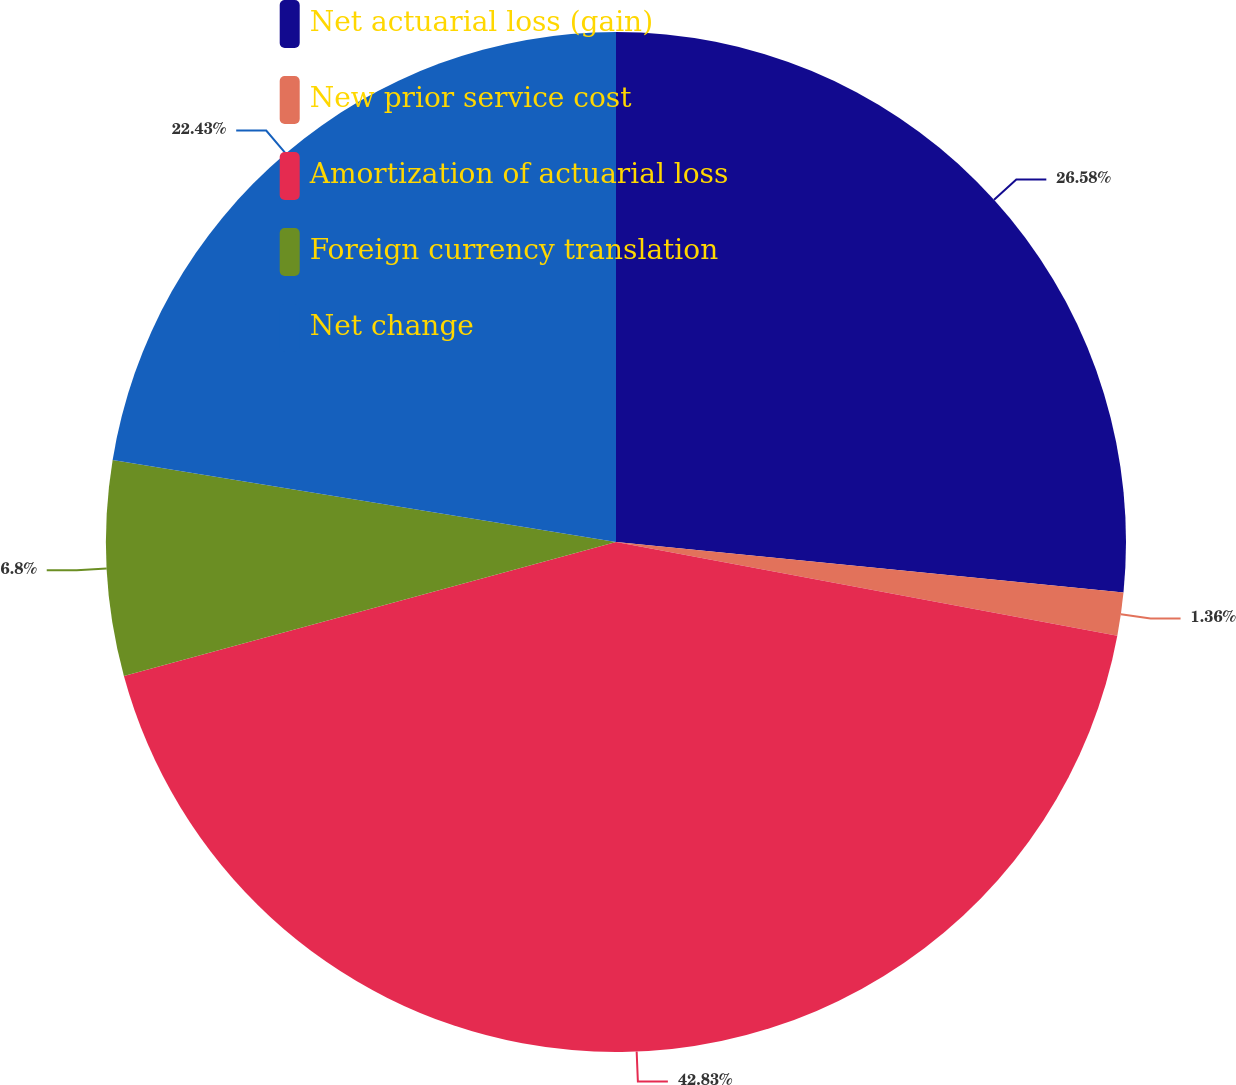Convert chart. <chart><loc_0><loc_0><loc_500><loc_500><pie_chart><fcel>Net actuarial loss (gain)<fcel>New prior service cost<fcel>Amortization of actuarial loss<fcel>Foreign currency translation<fcel>Net change<nl><fcel>26.58%<fcel>1.36%<fcel>42.83%<fcel>6.8%<fcel>22.43%<nl></chart> 